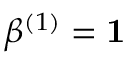Convert formula to latex. <formula><loc_0><loc_0><loc_500><loc_500>\beta ^ { ( 1 ) } = 1</formula> 